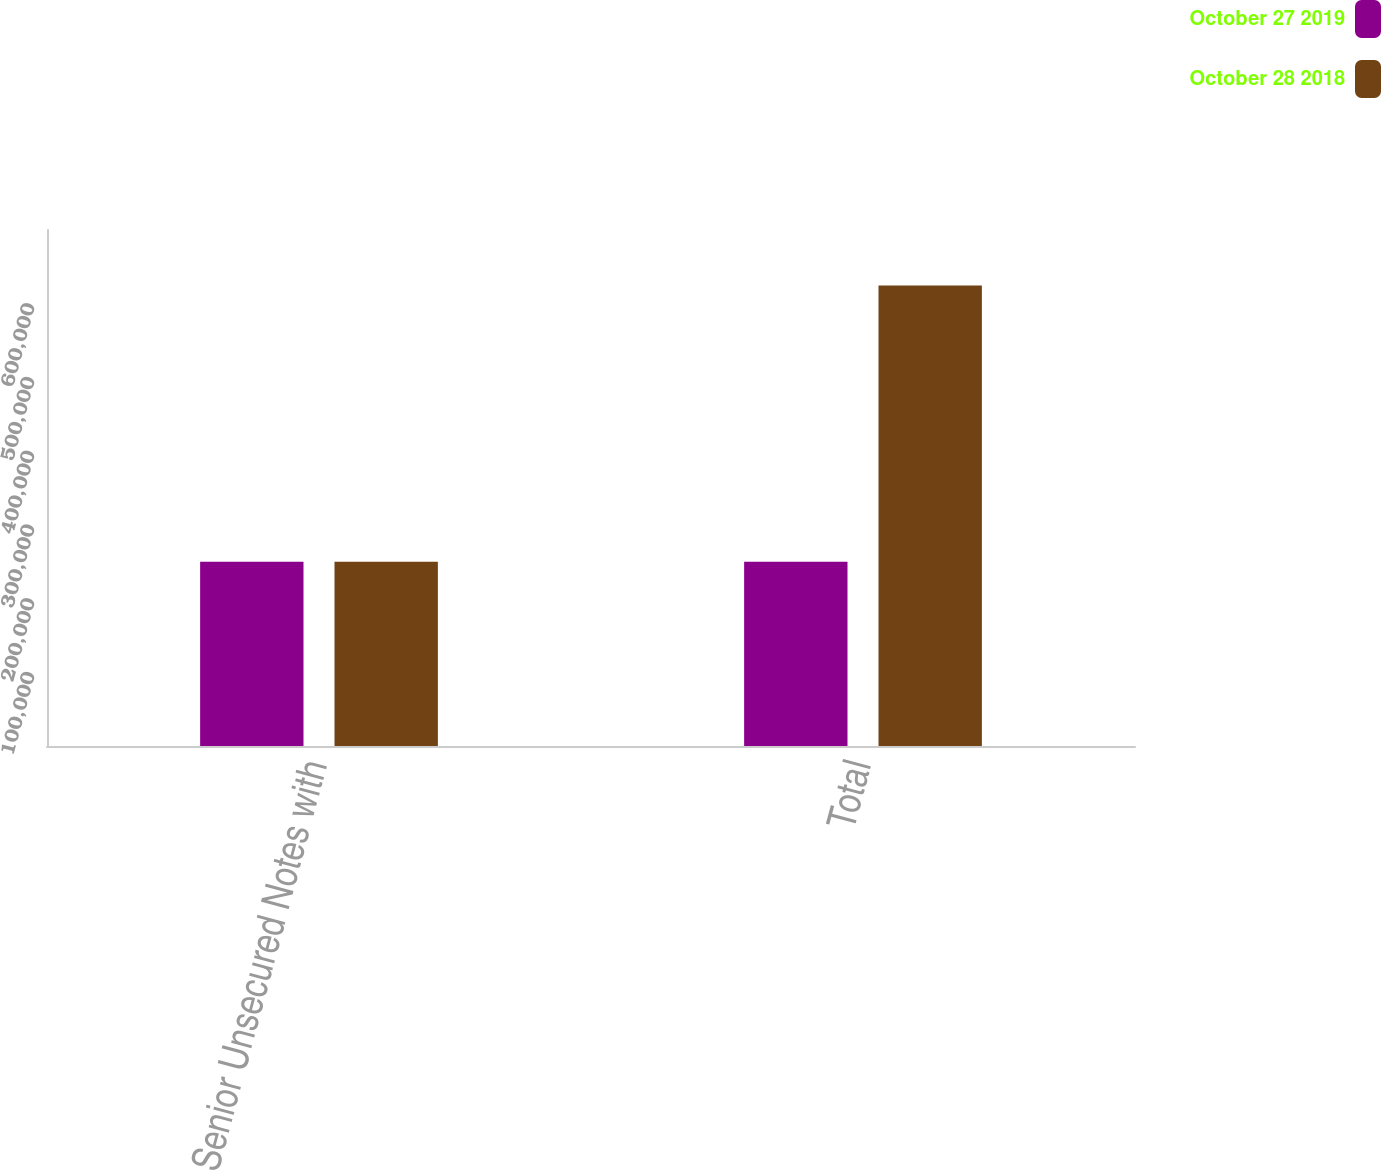Convert chart to OTSL. <chart><loc_0><loc_0><loc_500><loc_500><stacked_bar_chart><ecel><fcel>Senior Unsecured Notes with<fcel>Total<nl><fcel>October 27 2019<fcel>250000<fcel>250000<nl><fcel>October 28 2018<fcel>250000<fcel>624840<nl></chart> 